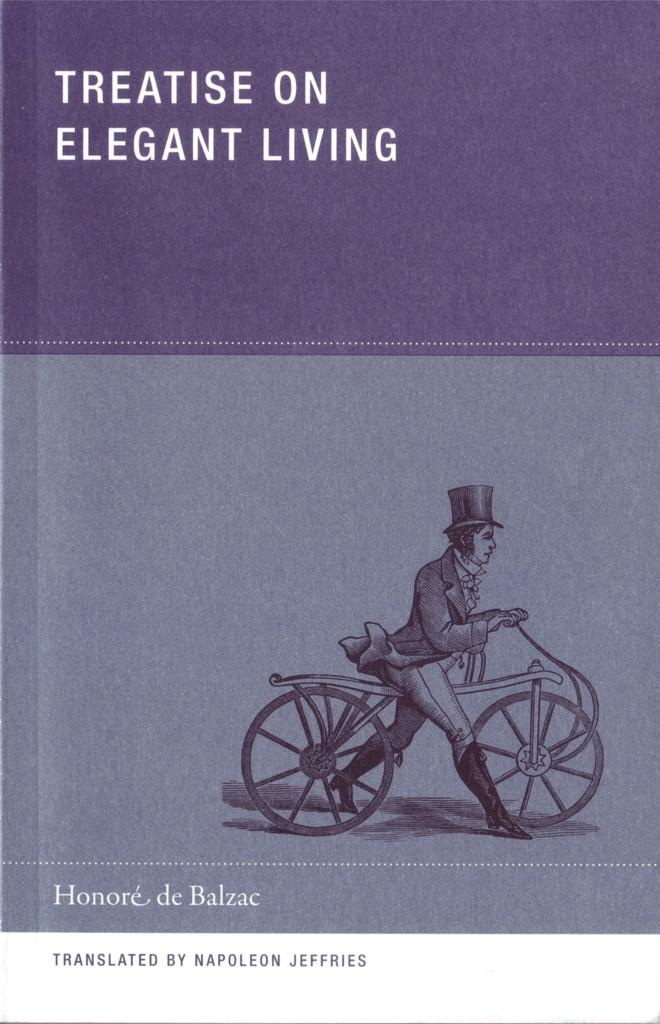What is featured in the picture? There is a poster in the picture. What can be found on the poster? There are words on the poster. What image is depicted on the poster? There is a photo of a person with a bicycle on the poster. Can you tell me how many frogs are sitting on the oven in the image? There are no frogs or ovens present in the image; it features a poster with words and a photo of a person with a bicycle. 